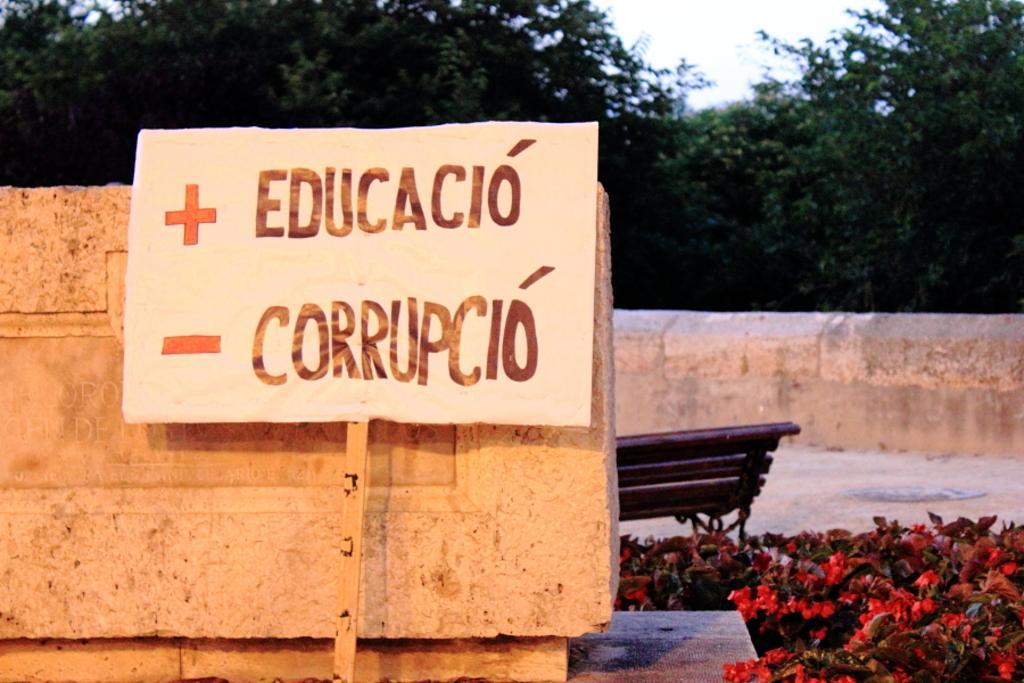Please provide a concise description of this image. In this picture we can see a white board on the wall. On the right there is a bench near to the plants. In the bottom right corner we can see red flowers in the plants. In the background we can see many trees. At the top there is a sky. 